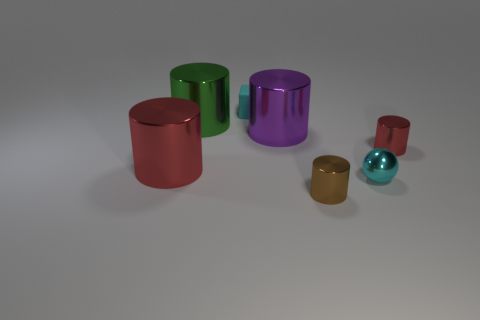Subtract all large purple cylinders. How many cylinders are left? 4 Subtract all purple cylinders. How many cylinders are left? 4 Subtract all cyan cylinders. Subtract all red balls. How many cylinders are left? 5 Add 1 large green objects. How many objects exist? 8 Subtract all cubes. How many objects are left? 6 Subtract all blocks. Subtract all matte cubes. How many objects are left? 5 Add 1 big red things. How many big red things are left? 2 Add 2 cyan metallic things. How many cyan metallic things exist? 3 Subtract 0 red balls. How many objects are left? 7 